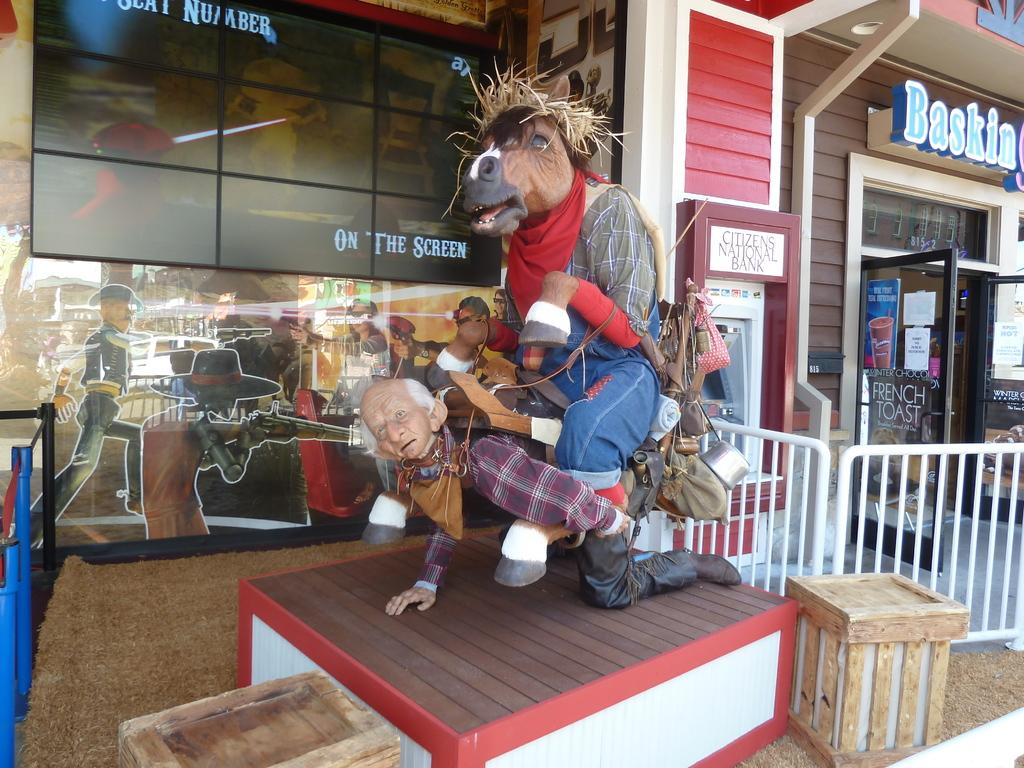What is the main subject in the middle of the image? There is a statue in the middle of the image. What can be seen on the right side of the image? There is a door on the right side of the image. What is written or depicted in the image? There is text and a poster in the image. What is visible in the background of the image? There is a building, glass, and text in the background of the image. How many shoes are on the statue's feet in the image? There are no shoes present on the statue in the image. What type of patch can be seen on the poster in the image? There is no patch visible on the poster in the image. 